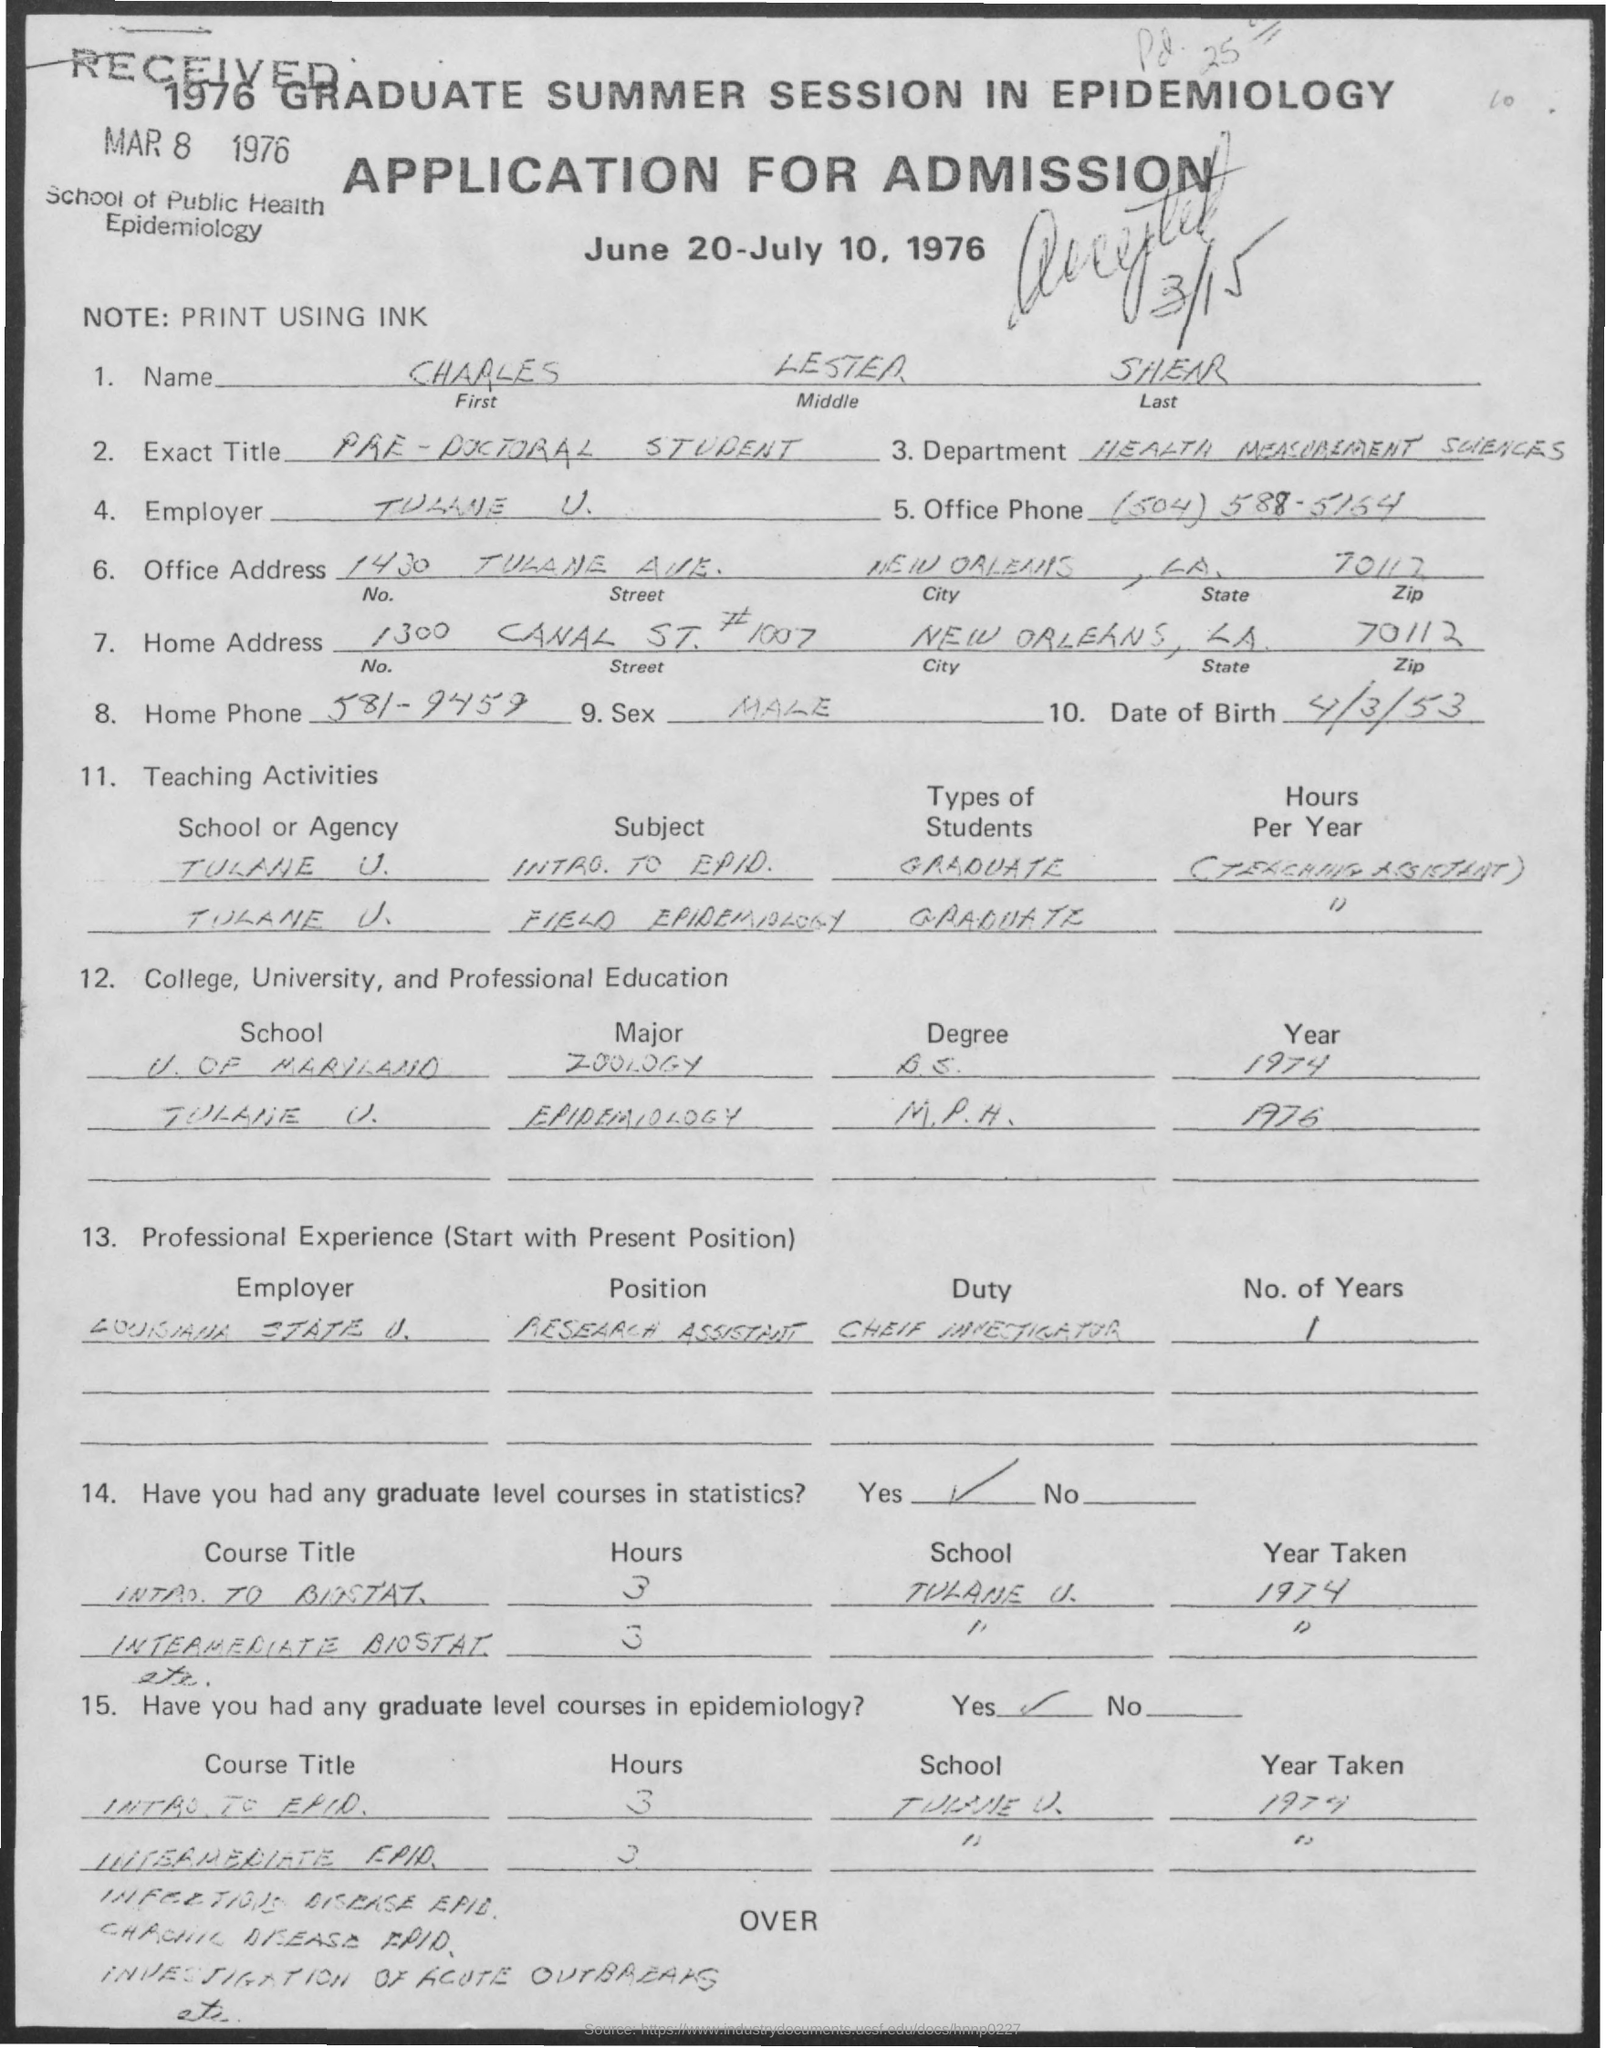Indicate a few pertinent items in this graphic. The office phone number mentioned in the given application is (504) 588-5164. In the given application, the name of the department mentioned is "Health Measurement Sciences". The dates mentioned for admission in the given application are June 20-July 10, 1976. The note mentioned in the given application is ink. The first name mentioned in the given application is Charles. 